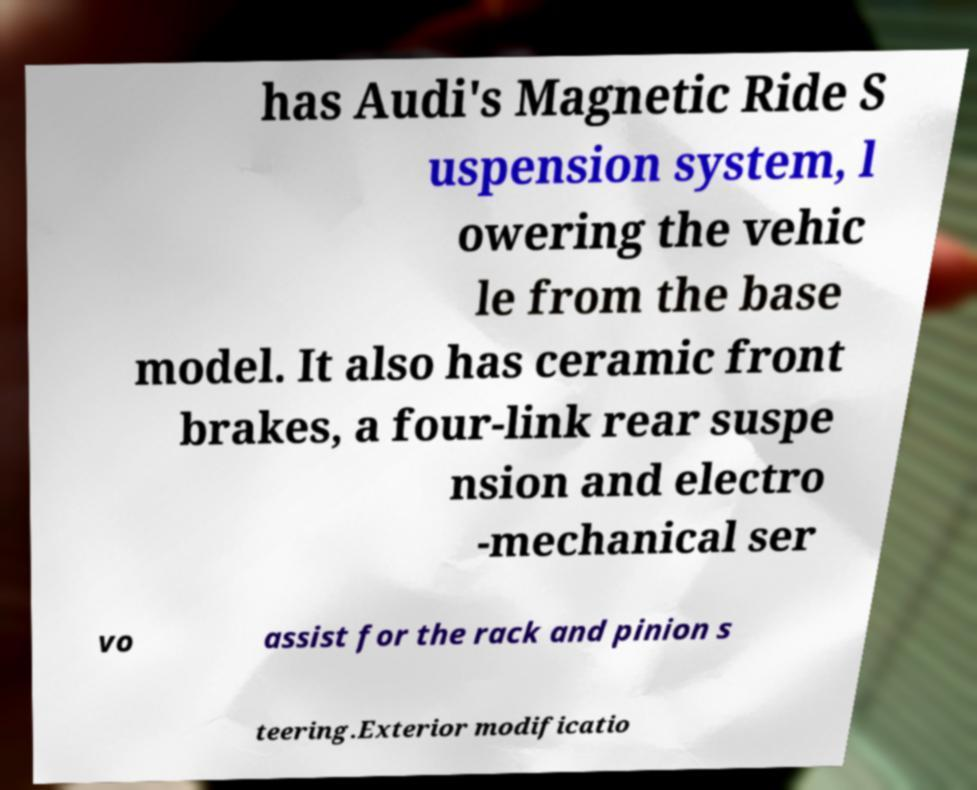There's text embedded in this image that I need extracted. Can you transcribe it verbatim? has Audi's Magnetic Ride S uspension system, l owering the vehic le from the base model. It also has ceramic front brakes, a four-link rear suspe nsion and electro -mechanical ser vo assist for the rack and pinion s teering.Exterior modificatio 